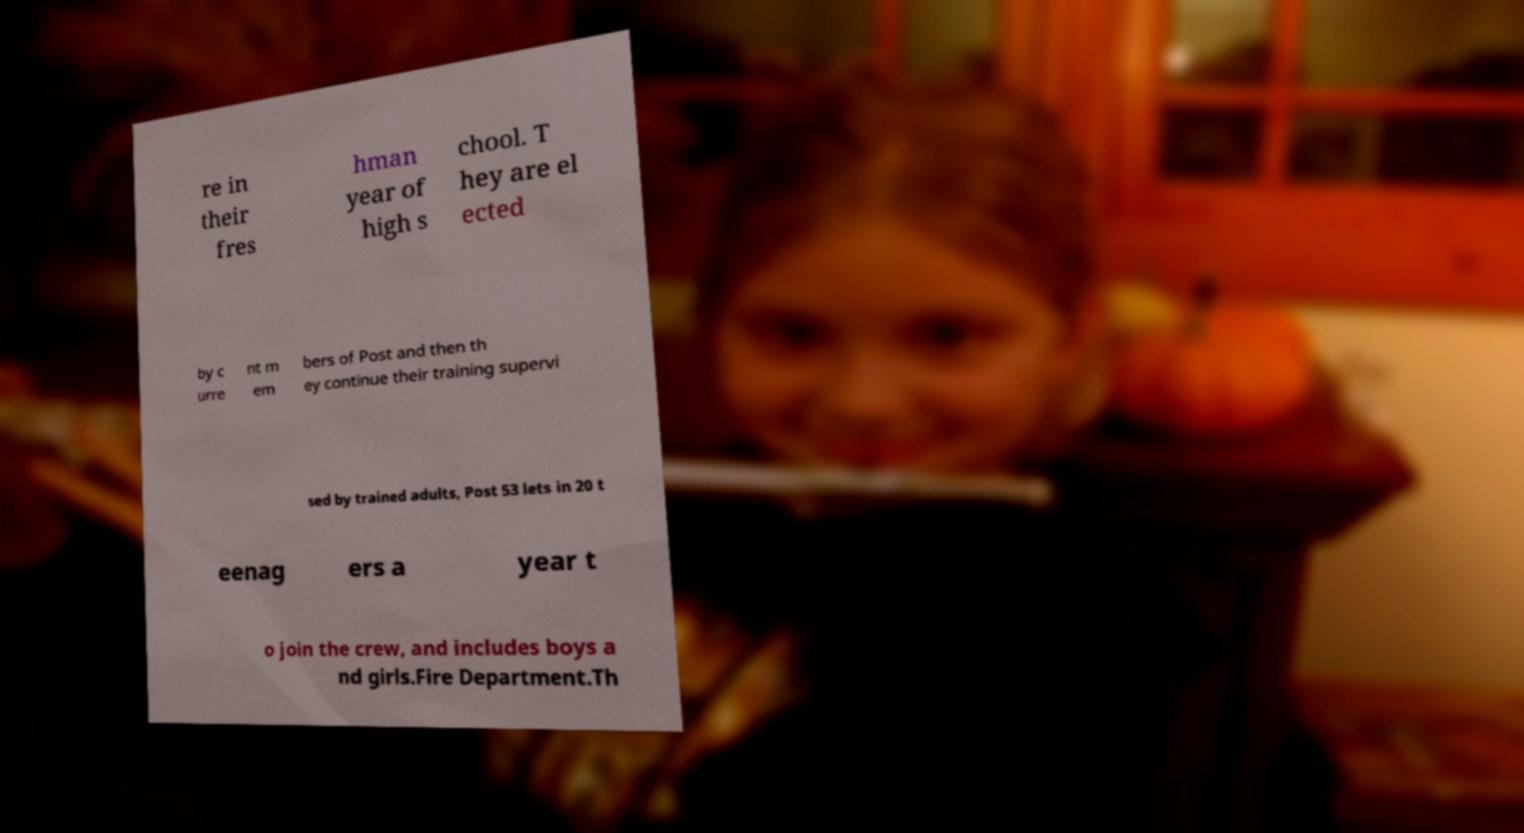Can you read and provide the text displayed in the image?This photo seems to have some interesting text. Can you extract and type it out for me? re in their fres hman year of high s chool. T hey are el ected by c urre nt m em bers of Post and then th ey continue their training supervi sed by trained adults, Post 53 lets in 20 t eenag ers a year t o join the crew, and includes boys a nd girls.Fire Department.Th 